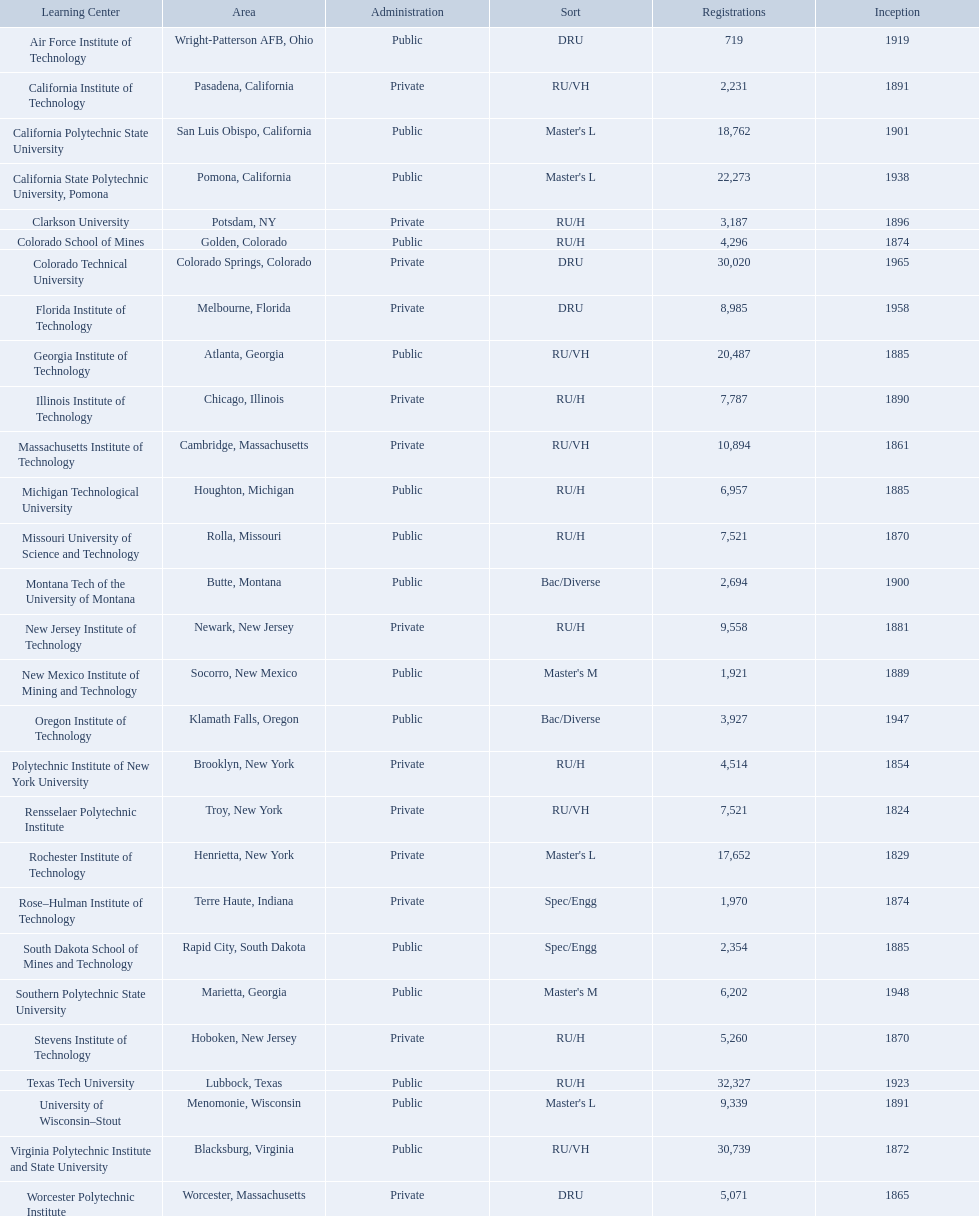What technical universities are in the united states? Air Force Institute of Technology, California Institute of Technology, California Polytechnic State University, California State Polytechnic University, Pomona, Clarkson University, Colorado School of Mines, Colorado Technical University, Florida Institute of Technology, Georgia Institute of Technology, Illinois Institute of Technology, Massachusetts Institute of Technology, Michigan Technological University, Missouri University of Science and Technology, Montana Tech of the University of Montana, New Jersey Institute of Technology, New Mexico Institute of Mining and Technology, Oregon Institute of Technology, Polytechnic Institute of New York University, Rensselaer Polytechnic Institute, Rochester Institute of Technology, Rose–Hulman Institute of Technology, South Dakota School of Mines and Technology, Southern Polytechnic State University, Stevens Institute of Technology, Texas Tech University, University of Wisconsin–Stout, Virginia Polytechnic Institute and State University, Worcester Polytechnic Institute. Which has the highest enrollment? Texas Tech University. What are all the schools? Air Force Institute of Technology, California Institute of Technology, California Polytechnic State University, California State Polytechnic University, Pomona, Clarkson University, Colorado School of Mines, Colorado Technical University, Florida Institute of Technology, Georgia Institute of Technology, Illinois Institute of Technology, Massachusetts Institute of Technology, Michigan Technological University, Missouri University of Science and Technology, Montana Tech of the University of Montana, New Jersey Institute of Technology, New Mexico Institute of Mining and Technology, Oregon Institute of Technology, Polytechnic Institute of New York University, Rensselaer Polytechnic Institute, Rochester Institute of Technology, Rose–Hulman Institute of Technology, South Dakota School of Mines and Technology, Southern Polytechnic State University, Stevens Institute of Technology, Texas Tech University, University of Wisconsin–Stout, Virginia Polytechnic Institute and State University, Worcester Polytechnic Institute. What is the enrollment of each school? 719, 2,231, 18,762, 22,273, 3,187, 4,296, 30,020, 8,985, 20,487, 7,787, 10,894, 6,957, 7,521, 2,694, 9,558, 1,921, 3,927, 4,514, 7,521, 17,652, 1,970, 2,354, 6,202, 5,260, 32,327, 9,339, 30,739, 5,071. And which school had the highest enrollment? Texas Tech University. 